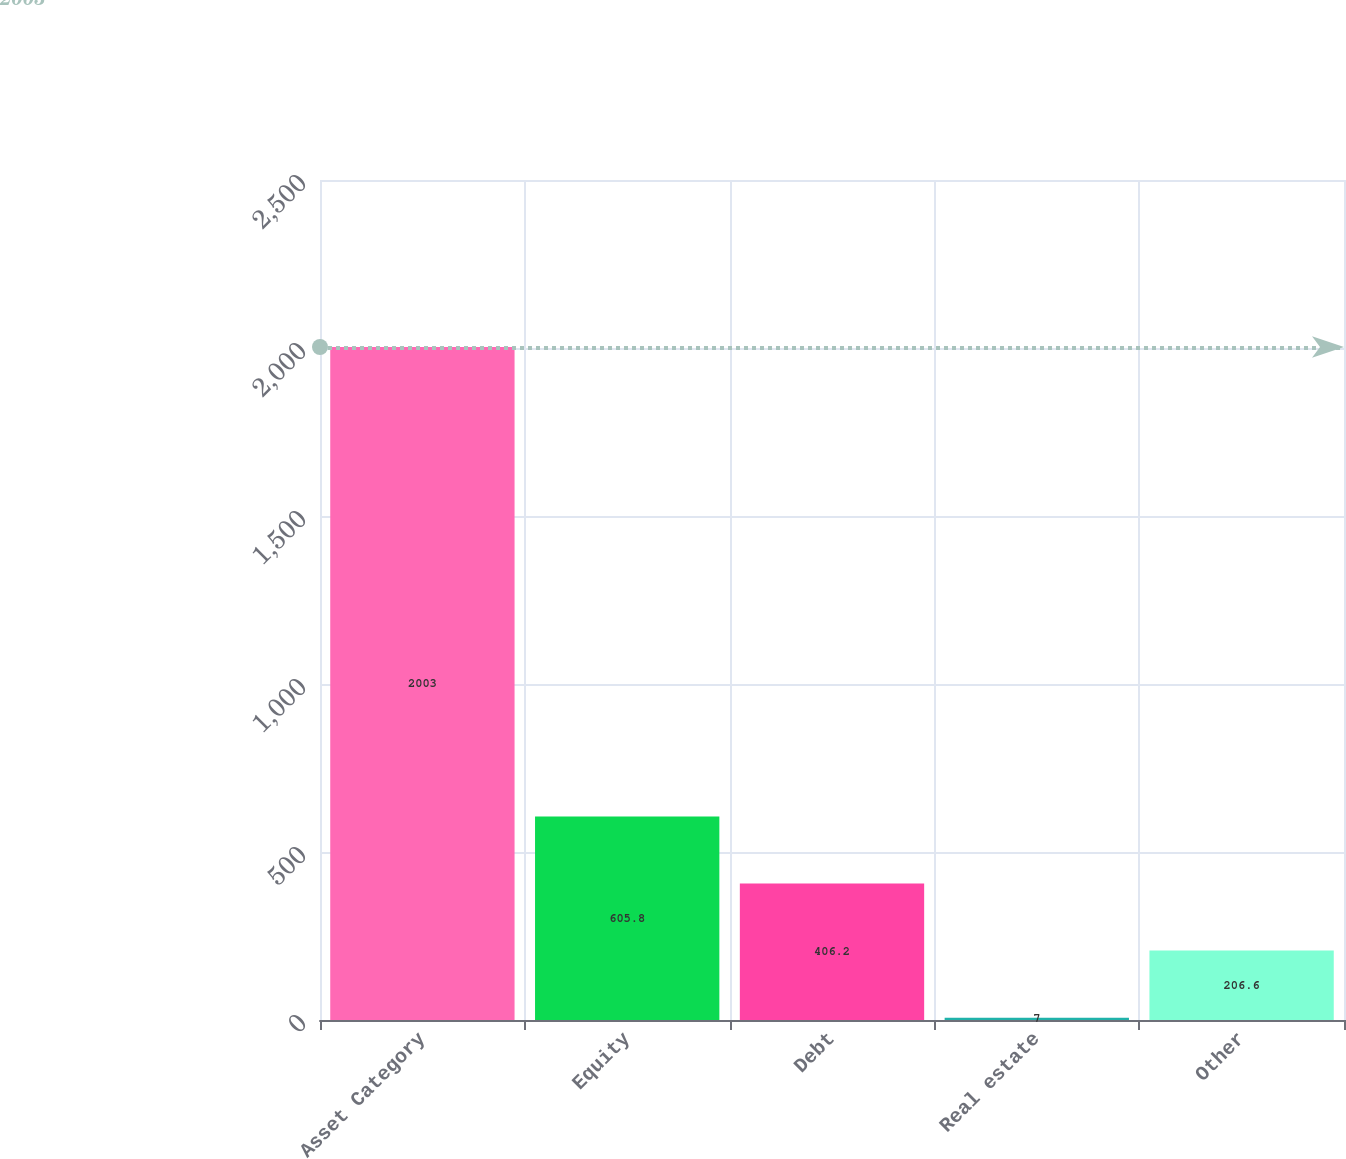<chart> <loc_0><loc_0><loc_500><loc_500><bar_chart><fcel>Asset Category<fcel>Equity<fcel>Debt<fcel>Real estate<fcel>Other<nl><fcel>2003<fcel>605.8<fcel>406.2<fcel>7<fcel>206.6<nl></chart> 